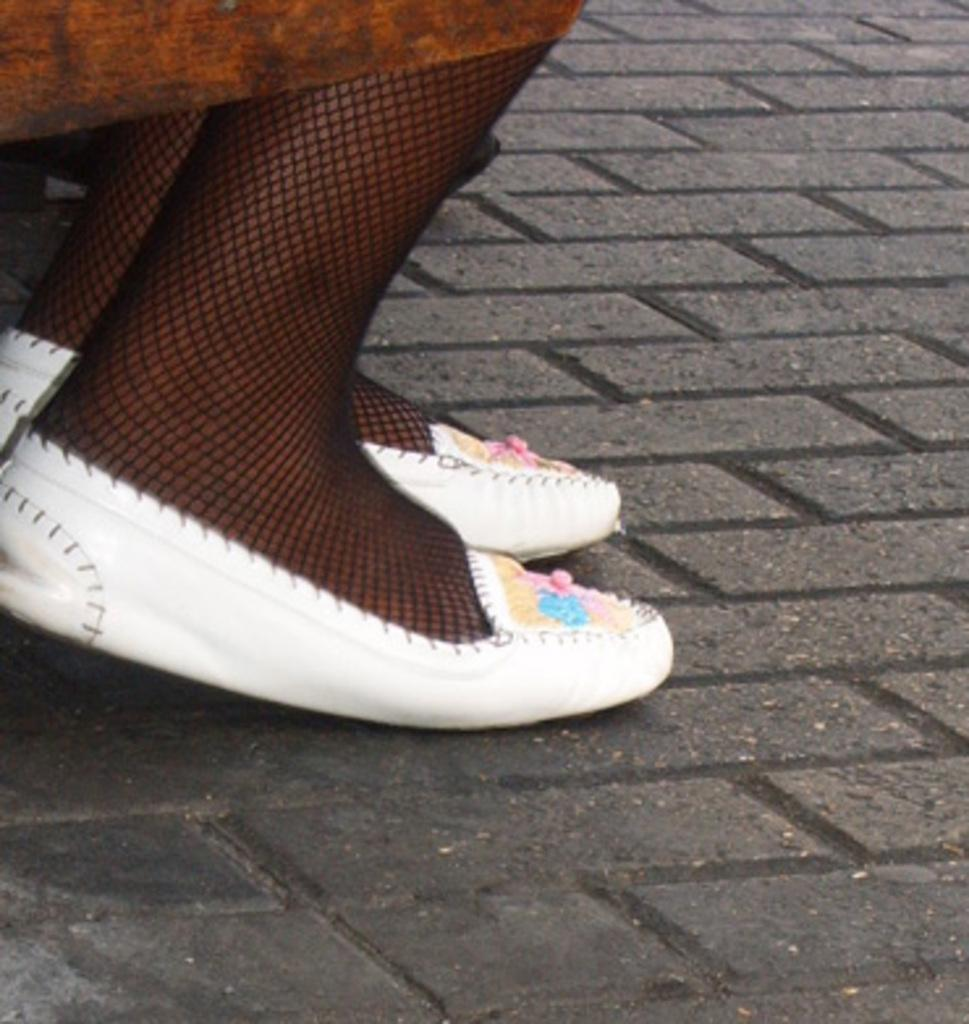What body part is visible in the image? There are a person's legs visible in the image. What type of footwear is the person wearing? The person is wearing white color shoes. What can be seen on the ground in the image? There is a path visible in the image. What type of plantation can be seen in the background of the image? There is no plantation visible in the image; it only shows a person's legs and a path. 